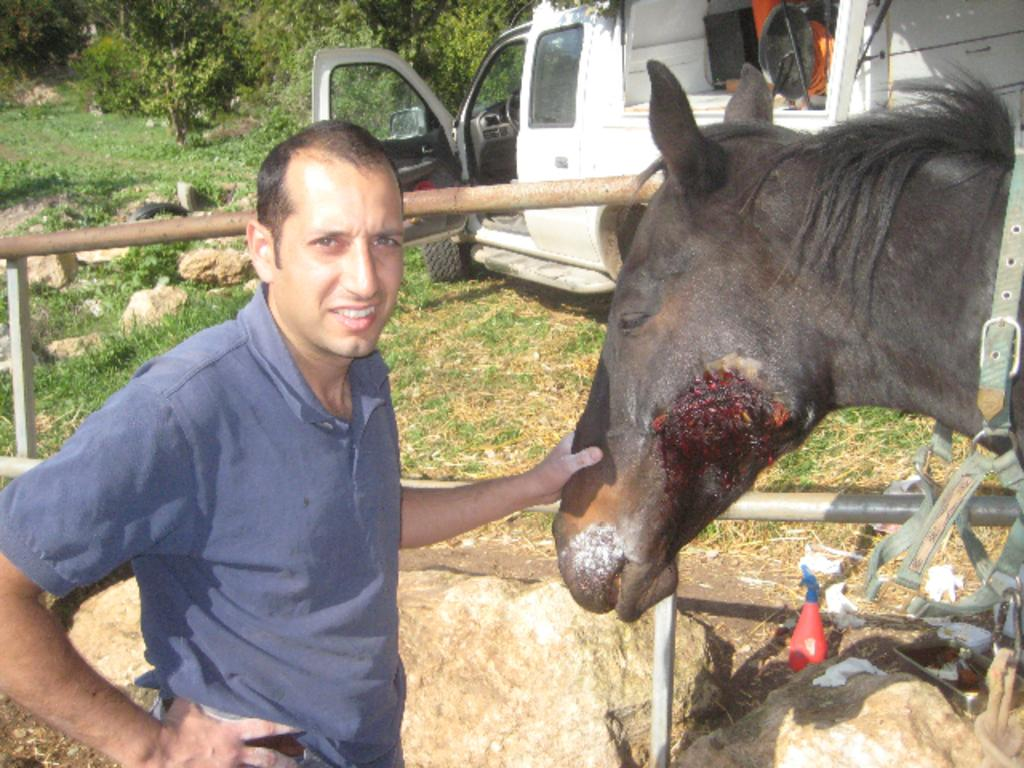What is the man in the image doing? The man is holding a horse in the image. What can be seen on the right side of the image? There is a white truck on the right side of the image. What type of vegetation is visible in the background of the image? There are trees visible in the background of the image. What object made of wood can be seen in the image? There is a wooden log in the image. What color is the rose that the man is holding in the image? There is no rose present in the image; the man is holding a horse. What time of day is depicted in the image? The time of day cannot be determined from the image alone, as there are no specific clues or indicators present. 